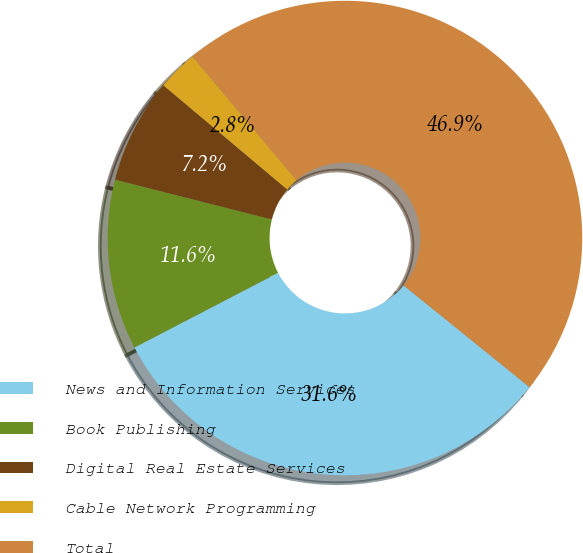Convert chart to OTSL. <chart><loc_0><loc_0><loc_500><loc_500><pie_chart><fcel>News and Information Services<fcel>Book Publishing<fcel>Digital Real Estate Services<fcel>Cable Network Programming<fcel>Total<nl><fcel>31.55%<fcel>11.59%<fcel>7.17%<fcel>2.75%<fcel>46.93%<nl></chart> 